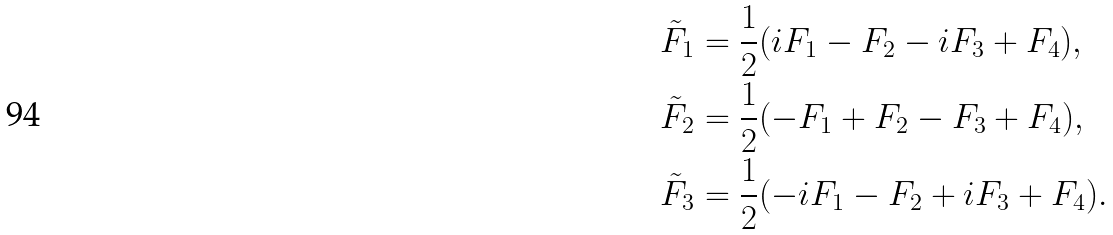<formula> <loc_0><loc_0><loc_500><loc_500>\tilde { F } _ { 1 } & = \frac { 1 } { 2 } ( i F _ { 1 } - F _ { 2 } - i F _ { 3 } + F _ { 4 } ) , \\ \tilde { F } _ { 2 } & = \frac { 1 } { 2 } ( - F _ { 1 } + F _ { 2 } - F _ { 3 } + F _ { 4 } ) , \\ \tilde { F } _ { 3 } & = \frac { 1 } { 2 } ( - i F _ { 1 } - F _ { 2 } + i F _ { 3 } + F _ { 4 } ) .</formula> 